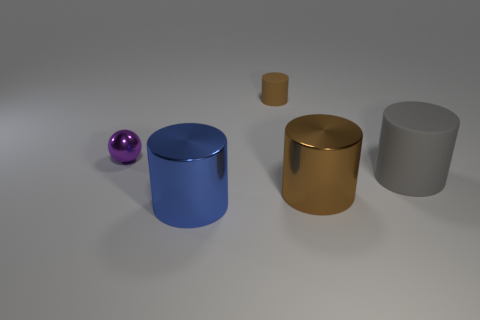The small purple thing that is made of the same material as the blue thing is what shape?
Offer a terse response. Sphere. There is a large metal cylinder that is to the right of the brown cylinder behind the large rubber object; what color is it?
Make the answer very short. Brown. What is the material of the big object that is on the left side of the brown thing that is in front of the big gray cylinder?
Your answer should be very brief. Metal. What material is the other small object that is the same shape as the gray object?
Offer a very short reply. Rubber. Is there a large brown cylinder to the right of the cylinder that is left of the matte cylinder that is behind the large gray cylinder?
Provide a succinct answer. Yes. What number of other objects are there of the same color as the small matte cylinder?
Provide a succinct answer. 1. How many metallic things are both to the right of the brown matte cylinder and left of the large blue cylinder?
Offer a very short reply. 0. What is the shape of the small shiny thing?
Offer a terse response. Sphere. What number of other things are there of the same material as the big gray cylinder
Provide a short and direct response. 1. What is the color of the metal thing that is behind the thing on the right side of the shiny cylinder on the right side of the big blue metal object?
Make the answer very short. Purple. 